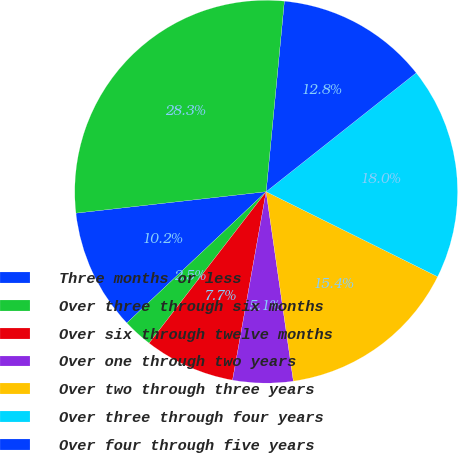Convert chart to OTSL. <chart><loc_0><loc_0><loc_500><loc_500><pie_chart><fcel>Three months or less<fcel>Over three through six months<fcel>Over six through twelve months<fcel>Over one through two years<fcel>Over two through three years<fcel>Over three through four years<fcel>Over four through five years<fcel>Total<nl><fcel>10.24%<fcel>2.5%<fcel>7.66%<fcel>5.08%<fcel>15.4%<fcel>17.98%<fcel>12.82%<fcel>28.3%<nl></chart> 